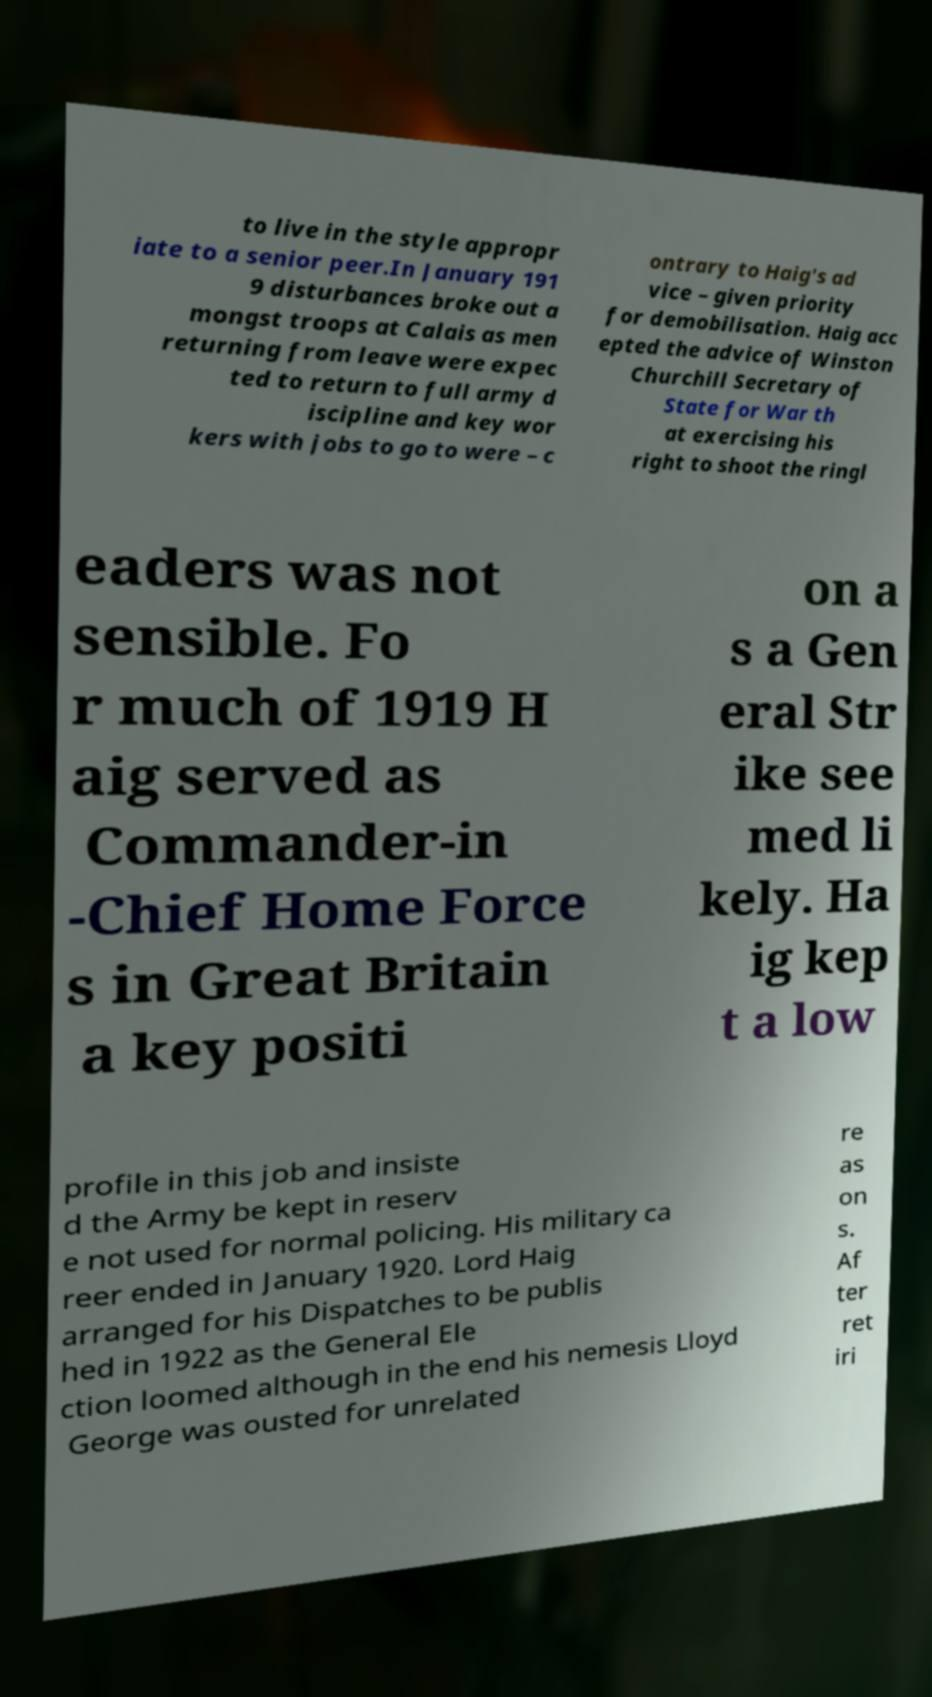What messages or text are displayed in this image? I need them in a readable, typed format. to live in the style appropr iate to a senior peer.In January 191 9 disturbances broke out a mongst troops at Calais as men returning from leave were expec ted to return to full army d iscipline and key wor kers with jobs to go to were – c ontrary to Haig's ad vice – given priority for demobilisation. Haig acc epted the advice of Winston Churchill Secretary of State for War th at exercising his right to shoot the ringl eaders was not sensible. Fo r much of 1919 H aig served as Commander-in -Chief Home Force s in Great Britain a key positi on a s a Gen eral Str ike see med li kely. Ha ig kep t a low profile in this job and insiste d the Army be kept in reserv e not used for normal policing. His military ca reer ended in January 1920. Lord Haig arranged for his Dispatches to be publis hed in 1922 as the General Ele ction loomed although in the end his nemesis Lloyd George was ousted for unrelated re as on s. Af ter ret iri 